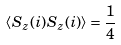<formula> <loc_0><loc_0><loc_500><loc_500>\left \langle S _ { z } ( i ) S _ { z } ( i ) \right \rangle = { \frac { 1 } { 4 } }</formula> 